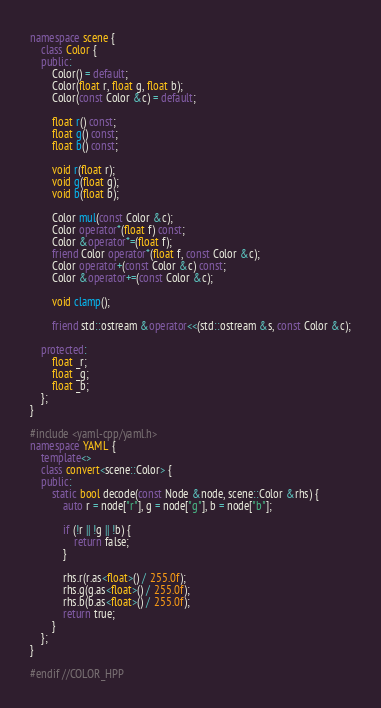<code> <loc_0><loc_0><loc_500><loc_500><_C++_>
namespace scene {
    class Color {
    public:
        Color() = default;
        Color(float r, float g, float b);
        Color(const Color &c) = default;

        float r() const;
        float g() const;
        float b() const;

        void r(float r);
        void g(float g);
        void b(float b);

        Color mul(const Color &c);
        Color operator*(float f) const;
        Color &operator*=(float f);
        friend Color operator*(float f, const Color &c);
        Color operator+(const Color &c) const;
        Color &operator+=(const Color &c);

        void clamp();

        friend std::ostream &operator<<(std::ostream &s, const Color &c);

    protected:
        float _r;
        float _g;
        float _b;
    };
}

#include <yaml-cpp/yaml.h>
namespace YAML {
    template<>
    class convert<scene::Color> {
    public:
        static bool decode(const Node &node, scene::Color &rhs) {
            auto r = node["r"], g = node["g"], b = node["b"];

            if (!r || !g || !b) {
                return false;
            }

            rhs.r(r.as<float>() / 255.0f);
            rhs.g(g.as<float>() / 255.0f);
            rhs.b(b.as<float>() / 255.0f);
            return true;
        }
    };
}

#endif //COLOR_HPP</code> 